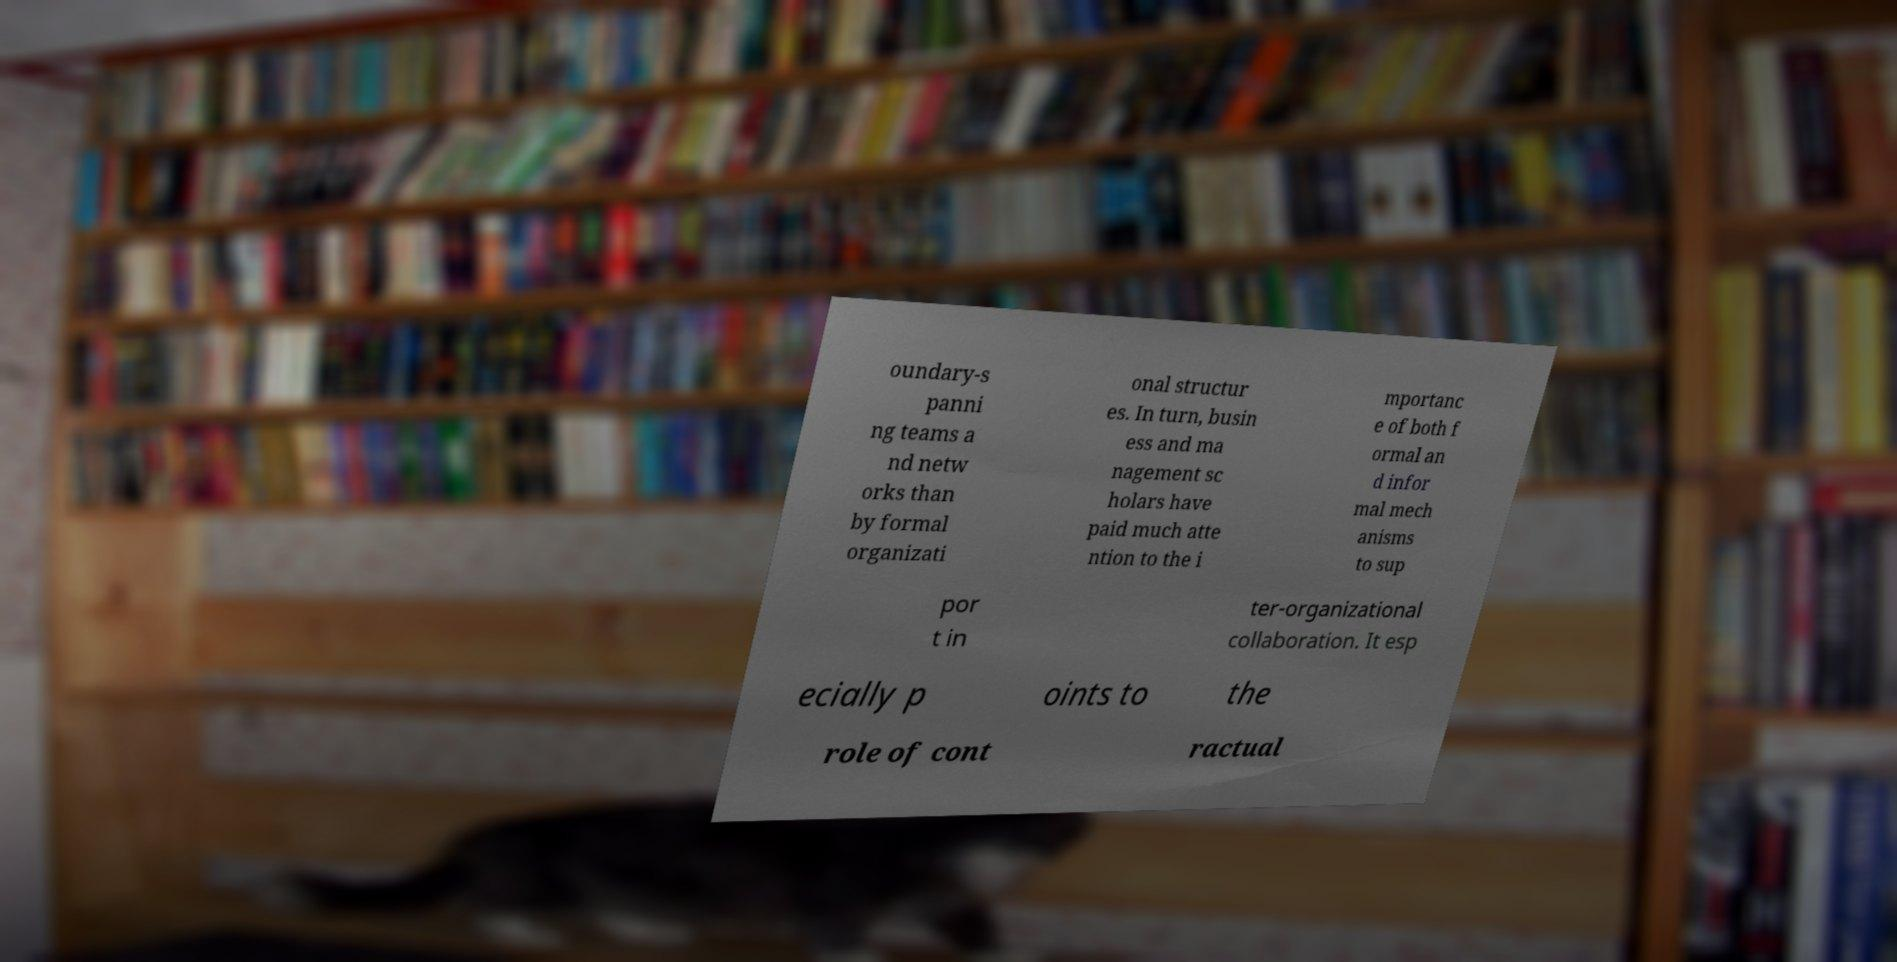Please read and relay the text visible in this image. What does it say? oundary-s panni ng teams a nd netw orks than by formal organizati onal structur es. In turn, busin ess and ma nagement sc holars have paid much atte ntion to the i mportanc e of both f ormal an d infor mal mech anisms to sup por t in ter-organizational collaboration. It esp ecially p oints to the role of cont ractual 